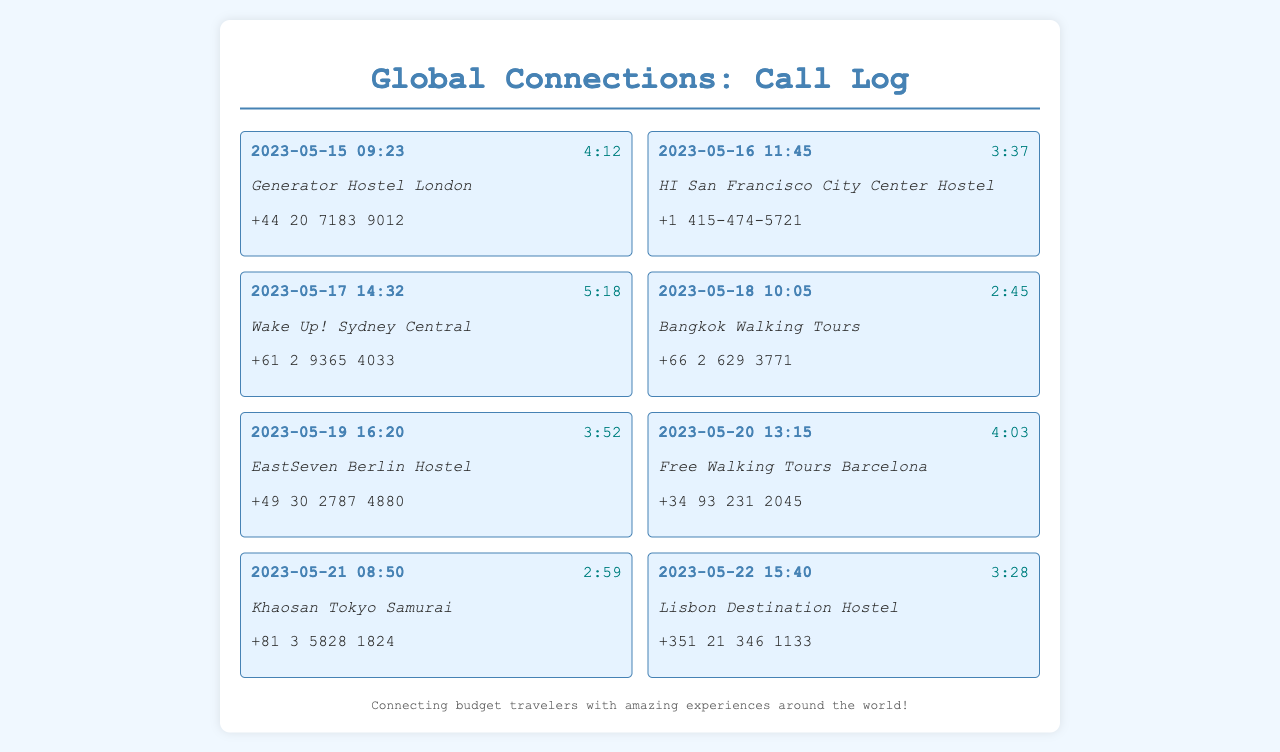What is the date of the call to Generator Hostel London? The call to Generator Hostel London was made on May 15, 2023.
Answer: May 15, 2023 How long was the call to HI San Francisco City Center Hostel? The call duration to HI San Francisco City Center Hostel was 3 minutes and 37 seconds.
Answer: 3:37 What is the phone number for Wake Up! Sydney Central? The phone number for Wake Up! Sydney Central is +61 2 9365 4033.
Answer: +61 2 9365 4033 Which hostel had the longest call duration? The longest call duration was for Wake Up! Sydney Central, lasting 5 minutes and 18 seconds.
Answer: Wake Up! Sydney Central What are the call durations for calls made on May 20 and May 21, respectively? The call durations are 4 minutes and 3 seconds for May 20 and 2 minutes and 59 seconds for May 21.
Answer: 4:03 and 2:59 How many calls were made to tour agencies? There was 1 call made to a tour agency, specifically to Bangkok Walking Tours.
Answer: 1 Which city is Khaosan Tokyo Samurai located in? Khaosan Tokyo Samurai is located in Tokyo.
Answer: Tokyo What is the contact name for the call made on May 22? The contact name for the call made on May 22 is Lisbon Destination Hostel.
Answer: Lisbon Destination Hostel When was the last call recorded in the document? The last call recorded in the document was on May 22, 2023.
Answer: May 22, 2023 